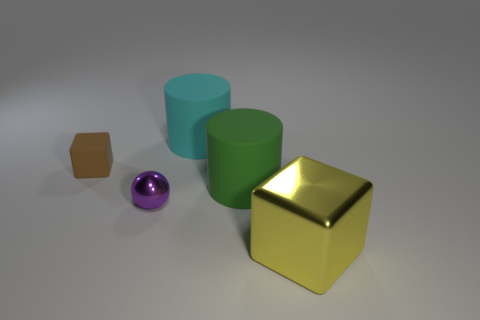There is a green thing behind the tiny metal object; does it have the same size as the block that is behind the green matte thing? The green cylindrical object behind the tiny metal sphere is larger than the brown block located behind the green matte cylinder. The sizes are not the same; the green cylinder is considerably larger in height and diameter. 